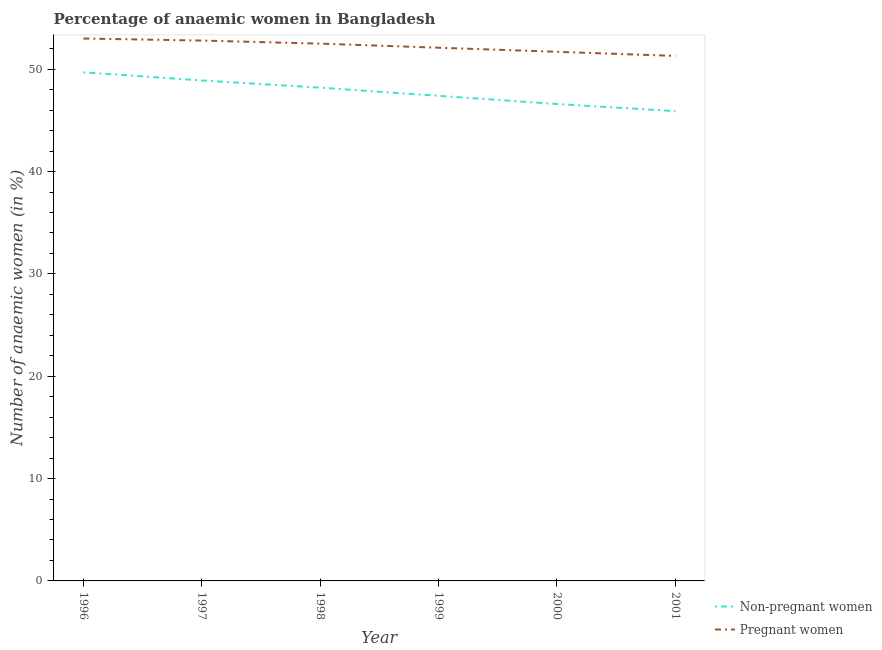How many different coloured lines are there?
Your answer should be very brief. 2. Does the line corresponding to percentage of non-pregnant anaemic women intersect with the line corresponding to percentage of pregnant anaemic women?
Keep it short and to the point. No. What is the percentage of non-pregnant anaemic women in 2001?
Your answer should be compact. 45.9. Across all years, what is the maximum percentage of pregnant anaemic women?
Your answer should be very brief. 53. Across all years, what is the minimum percentage of pregnant anaemic women?
Keep it short and to the point. 51.3. What is the total percentage of non-pregnant anaemic women in the graph?
Your answer should be compact. 286.7. What is the difference between the percentage of pregnant anaemic women in 1998 and that in 2001?
Your response must be concise. 1.2. What is the difference between the percentage of non-pregnant anaemic women in 2000 and the percentage of pregnant anaemic women in 2001?
Keep it short and to the point. -4.7. What is the average percentage of pregnant anaemic women per year?
Your answer should be compact. 52.23. In the year 1999, what is the difference between the percentage of pregnant anaemic women and percentage of non-pregnant anaemic women?
Offer a terse response. 4.7. What is the ratio of the percentage of non-pregnant anaemic women in 1996 to that in 1998?
Your answer should be compact. 1.03. What is the difference between the highest and the second highest percentage of non-pregnant anaemic women?
Give a very brief answer. 0.8. What is the difference between the highest and the lowest percentage of pregnant anaemic women?
Your answer should be very brief. 1.7. In how many years, is the percentage of non-pregnant anaemic women greater than the average percentage of non-pregnant anaemic women taken over all years?
Your answer should be compact. 3. Is the sum of the percentage of pregnant anaemic women in 1997 and 1999 greater than the maximum percentage of non-pregnant anaemic women across all years?
Provide a succinct answer. Yes. Is the percentage of non-pregnant anaemic women strictly greater than the percentage of pregnant anaemic women over the years?
Your answer should be very brief. No. What is the difference between two consecutive major ticks on the Y-axis?
Offer a very short reply. 10. Are the values on the major ticks of Y-axis written in scientific E-notation?
Your answer should be compact. No. Does the graph contain any zero values?
Keep it short and to the point. No. Does the graph contain grids?
Make the answer very short. No. How many legend labels are there?
Provide a succinct answer. 2. What is the title of the graph?
Ensure brevity in your answer.  Percentage of anaemic women in Bangladesh. What is the label or title of the X-axis?
Offer a very short reply. Year. What is the label or title of the Y-axis?
Ensure brevity in your answer.  Number of anaemic women (in %). What is the Number of anaemic women (in %) in Non-pregnant women in 1996?
Your response must be concise. 49.7. What is the Number of anaemic women (in %) in Non-pregnant women in 1997?
Provide a succinct answer. 48.9. What is the Number of anaemic women (in %) of Pregnant women in 1997?
Give a very brief answer. 52.8. What is the Number of anaemic women (in %) of Non-pregnant women in 1998?
Your answer should be very brief. 48.2. What is the Number of anaemic women (in %) of Pregnant women in 1998?
Keep it short and to the point. 52.5. What is the Number of anaemic women (in %) in Non-pregnant women in 1999?
Your response must be concise. 47.4. What is the Number of anaemic women (in %) in Pregnant women in 1999?
Your response must be concise. 52.1. What is the Number of anaemic women (in %) in Non-pregnant women in 2000?
Offer a very short reply. 46.6. What is the Number of anaemic women (in %) of Pregnant women in 2000?
Provide a succinct answer. 51.7. What is the Number of anaemic women (in %) in Non-pregnant women in 2001?
Keep it short and to the point. 45.9. What is the Number of anaemic women (in %) of Pregnant women in 2001?
Make the answer very short. 51.3. Across all years, what is the maximum Number of anaemic women (in %) of Non-pregnant women?
Your answer should be very brief. 49.7. Across all years, what is the minimum Number of anaemic women (in %) in Non-pregnant women?
Give a very brief answer. 45.9. Across all years, what is the minimum Number of anaemic women (in %) in Pregnant women?
Offer a terse response. 51.3. What is the total Number of anaemic women (in %) of Non-pregnant women in the graph?
Your answer should be compact. 286.7. What is the total Number of anaemic women (in %) in Pregnant women in the graph?
Provide a short and direct response. 313.4. What is the difference between the Number of anaemic women (in %) in Pregnant women in 1996 and that in 1997?
Provide a short and direct response. 0.2. What is the difference between the Number of anaemic women (in %) in Pregnant women in 1996 and that in 1998?
Give a very brief answer. 0.5. What is the difference between the Number of anaemic women (in %) in Non-pregnant women in 1996 and that in 1999?
Keep it short and to the point. 2.3. What is the difference between the Number of anaemic women (in %) of Pregnant women in 1996 and that in 1999?
Your answer should be very brief. 0.9. What is the difference between the Number of anaemic women (in %) of Non-pregnant women in 1996 and that in 2000?
Your response must be concise. 3.1. What is the difference between the Number of anaemic women (in %) in Pregnant women in 1996 and that in 2000?
Provide a succinct answer. 1.3. What is the difference between the Number of anaemic women (in %) of Non-pregnant women in 1996 and that in 2001?
Offer a terse response. 3.8. What is the difference between the Number of anaemic women (in %) of Pregnant women in 1997 and that in 1998?
Offer a very short reply. 0.3. What is the difference between the Number of anaemic women (in %) in Pregnant women in 1997 and that in 2000?
Provide a short and direct response. 1.1. What is the difference between the Number of anaemic women (in %) of Non-pregnant women in 1997 and that in 2001?
Provide a short and direct response. 3. What is the difference between the Number of anaemic women (in %) in Pregnant women in 1997 and that in 2001?
Your response must be concise. 1.5. What is the difference between the Number of anaemic women (in %) in Non-pregnant women in 1998 and that in 1999?
Offer a terse response. 0.8. What is the difference between the Number of anaemic women (in %) of Pregnant women in 1998 and that in 1999?
Your response must be concise. 0.4. What is the difference between the Number of anaemic women (in %) in Pregnant women in 1998 and that in 2001?
Provide a succinct answer. 1.2. What is the difference between the Number of anaemic women (in %) in Non-pregnant women in 1999 and that in 2000?
Your response must be concise. 0.8. What is the difference between the Number of anaemic women (in %) of Non-pregnant women in 2000 and that in 2001?
Offer a very short reply. 0.7. What is the difference between the Number of anaemic women (in %) in Pregnant women in 2000 and that in 2001?
Provide a succinct answer. 0.4. What is the difference between the Number of anaemic women (in %) of Non-pregnant women in 1996 and the Number of anaemic women (in %) of Pregnant women in 1997?
Your answer should be very brief. -3.1. What is the difference between the Number of anaemic women (in %) in Non-pregnant women in 1996 and the Number of anaemic women (in %) in Pregnant women in 2000?
Ensure brevity in your answer.  -2. What is the difference between the Number of anaemic women (in %) in Non-pregnant women in 1997 and the Number of anaemic women (in %) in Pregnant women in 1998?
Offer a terse response. -3.6. What is the difference between the Number of anaemic women (in %) of Non-pregnant women in 1997 and the Number of anaemic women (in %) of Pregnant women in 1999?
Ensure brevity in your answer.  -3.2. What is the difference between the Number of anaemic women (in %) of Non-pregnant women in 1997 and the Number of anaemic women (in %) of Pregnant women in 2000?
Offer a terse response. -2.8. What is the difference between the Number of anaemic women (in %) of Non-pregnant women in 1997 and the Number of anaemic women (in %) of Pregnant women in 2001?
Offer a very short reply. -2.4. What is the difference between the Number of anaemic women (in %) of Non-pregnant women in 1998 and the Number of anaemic women (in %) of Pregnant women in 2000?
Offer a very short reply. -3.5. What is the difference between the Number of anaemic women (in %) of Non-pregnant women in 1998 and the Number of anaemic women (in %) of Pregnant women in 2001?
Your answer should be compact. -3.1. What is the difference between the Number of anaemic women (in %) in Non-pregnant women in 1999 and the Number of anaemic women (in %) in Pregnant women in 2000?
Your answer should be very brief. -4.3. What is the difference between the Number of anaemic women (in %) in Non-pregnant women in 1999 and the Number of anaemic women (in %) in Pregnant women in 2001?
Give a very brief answer. -3.9. What is the difference between the Number of anaemic women (in %) of Non-pregnant women in 2000 and the Number of anaemic women (in %) of Pregnant women in 2001?
Your response must be concise. -4.7. What is the average Number of anaemic women (in %) in Non-pregnant women per year?
Your answer should be compact. 47.78. What is the average Number of anaemic women (in %) in Pregnant women per year?
Give a very brief answer. 52.23. In the year 1998, what is the difference between the Number of anaemic women (in %) in Non-pregnant women and Number of anaemic women (in %) in Pregnant women?
Your answer should be compact. -4.3. In the year 2000, what is the difference between the Number of anaemic women (in %) of Non-pregnant women and Number of anaemic women (in %) of Pregnant women?
Give a very brief answer. -5.1. What is the ratio of the Number of anaemic women (in %) in Non-pregnant women in 1996 to that in 1997?
Keep it short and to the point. 1.02. What is the ratio of the Number of anaemic women (in %) in Pregnant women in 1996 to that in 1997?
Make the answer very short. 1. What is the ratio of the Number of anaemic women (in %) of Non-pregnant women in 1996 to that in 1998?
Keep it short and to the point. 1.03. What is the ratio of the Number of anaemic women (in %) of Pregnant women in 1996 to that in 1998?
Give a very brief answer. 1.01. What is the ratio of the Number of anaemic women (in %) in Non-pregnant women in 1996 to that in 1999?
Offer a terse response. 1.05. What is the ratio of the Number of anaemic women (in %) of Pregnant women in 1996 to that in 1999?
Your answer should be very brief. 1.02. What is the ratio of the Number of anaemic women (in %) of Non-pregnant women in 1996 to that in 2000?
Your answer should be compact. 1.07. What is the ratio of the Number of anaemic women (in %) in Pregnant women in 1996 to that in 2000?
Your answer should be compact. 1.03. What is the ratio of the Number of anaemic women (in %) in Non-pregnant women in 1996 to that in 2001?
Make the answer very short. 1.08. What is the ratio of the Number of anaemic women (in %) of Pregnant women in 1996 to that in 2001?
Your answer should be compact. 1.03. What is the ratio of the Number of anaemic women (in %) in Non-pregnant women in 1997 to that in 1998?
Your answer should be very brief. 1.01. What is the ratio of the Number of anaemic women (in %) in Non-pregnant women in 1997 to that in 1999?
Your answer should be compact. 1.03. What is the ratio of the Number of anaemic women (in %) of Pregnant women in 1997 to that in 1999?
Make the answer very short. 1.01. What is the ratio of the Number of anaemic women (in %) in Non-pregnant women in 1997 to that in 2000?
Your answer should be very brief. 1.05. What is the ratio of the Number of anaemic women (in %) of Pregnant women in 1997 to that in 2000?
Make the answer very short. 1.02. What is the ratio of the Number of anaemic women (in %) in Non-pregnant women in 1997 to that in 2001?
Your answer should be very brief. 1.07. What is the ratio of the Number of anaemic women (in %) in Pregnant women in 1997 to that in 2001?
Offer a very short reply. 1.03. What is the ratio of the Number of anaemic women (in %) of Non-pregnant women in 1998 to that in 1999?
Offer a very short reply. 1.02. What is the ratio of the Number of anaemic women (in %) in Pregnant women in 1998 to that in 1999?
Provide a short and direct response. 1.01. What is the ratio of the Number of anaemic women (in %) of Non-pregnant women in 1998 to that in 2000?
Ensure brevity in your answer.  1.03. What is the ratio of the Number of anaemic women (in %) of Pregnant women in 1998 to that in 2000?
Provide a succinct answer. 1.02. What is the ratio of the Number of anaemic women (in %) of Non-pregnant women in 1998 to that in 2001?
Keep it short and to the point. 1.05. What is the ratio of the Number of anaemic women (in %) of Pregnant women in 1998 to that in 2001?
Offer a very short reply. 1.02. What is the ratio of the Number of anaemic women (in %) in Non-pregnant women in 1999 to that in 2000?
Your answer should be compact. 1.02. What is the ratio of the Number of anaemic women (in %) in Pregnant women in 1999 to that in 2000?
Offer a terse response. 1.01. What is the ratio of the Number of anaemic women (in %) of Non-pregnant women in 1999 to that in 2001?
Your response must be concise. 1.03. What is the ratio of the Number of anaemic women (in %) of Pregnant women in 1999 to that in 2001?
Your answer should be compact. 1.02. What is the ratio of the Number of anaemic women (in %) of Non-pregnant women in 2000 to that in 2001?
Your answer should be very brief. 1.02. What is the difference between the highest and the second highest Number of anaemic women (in %) in Pregnant women?
Offer a very short reply. 0.2. What is the difference between the highest and the lowest Number of anaemic women (in %) in Non-pregnant women?
Provide a short and direct response. 3.8. 